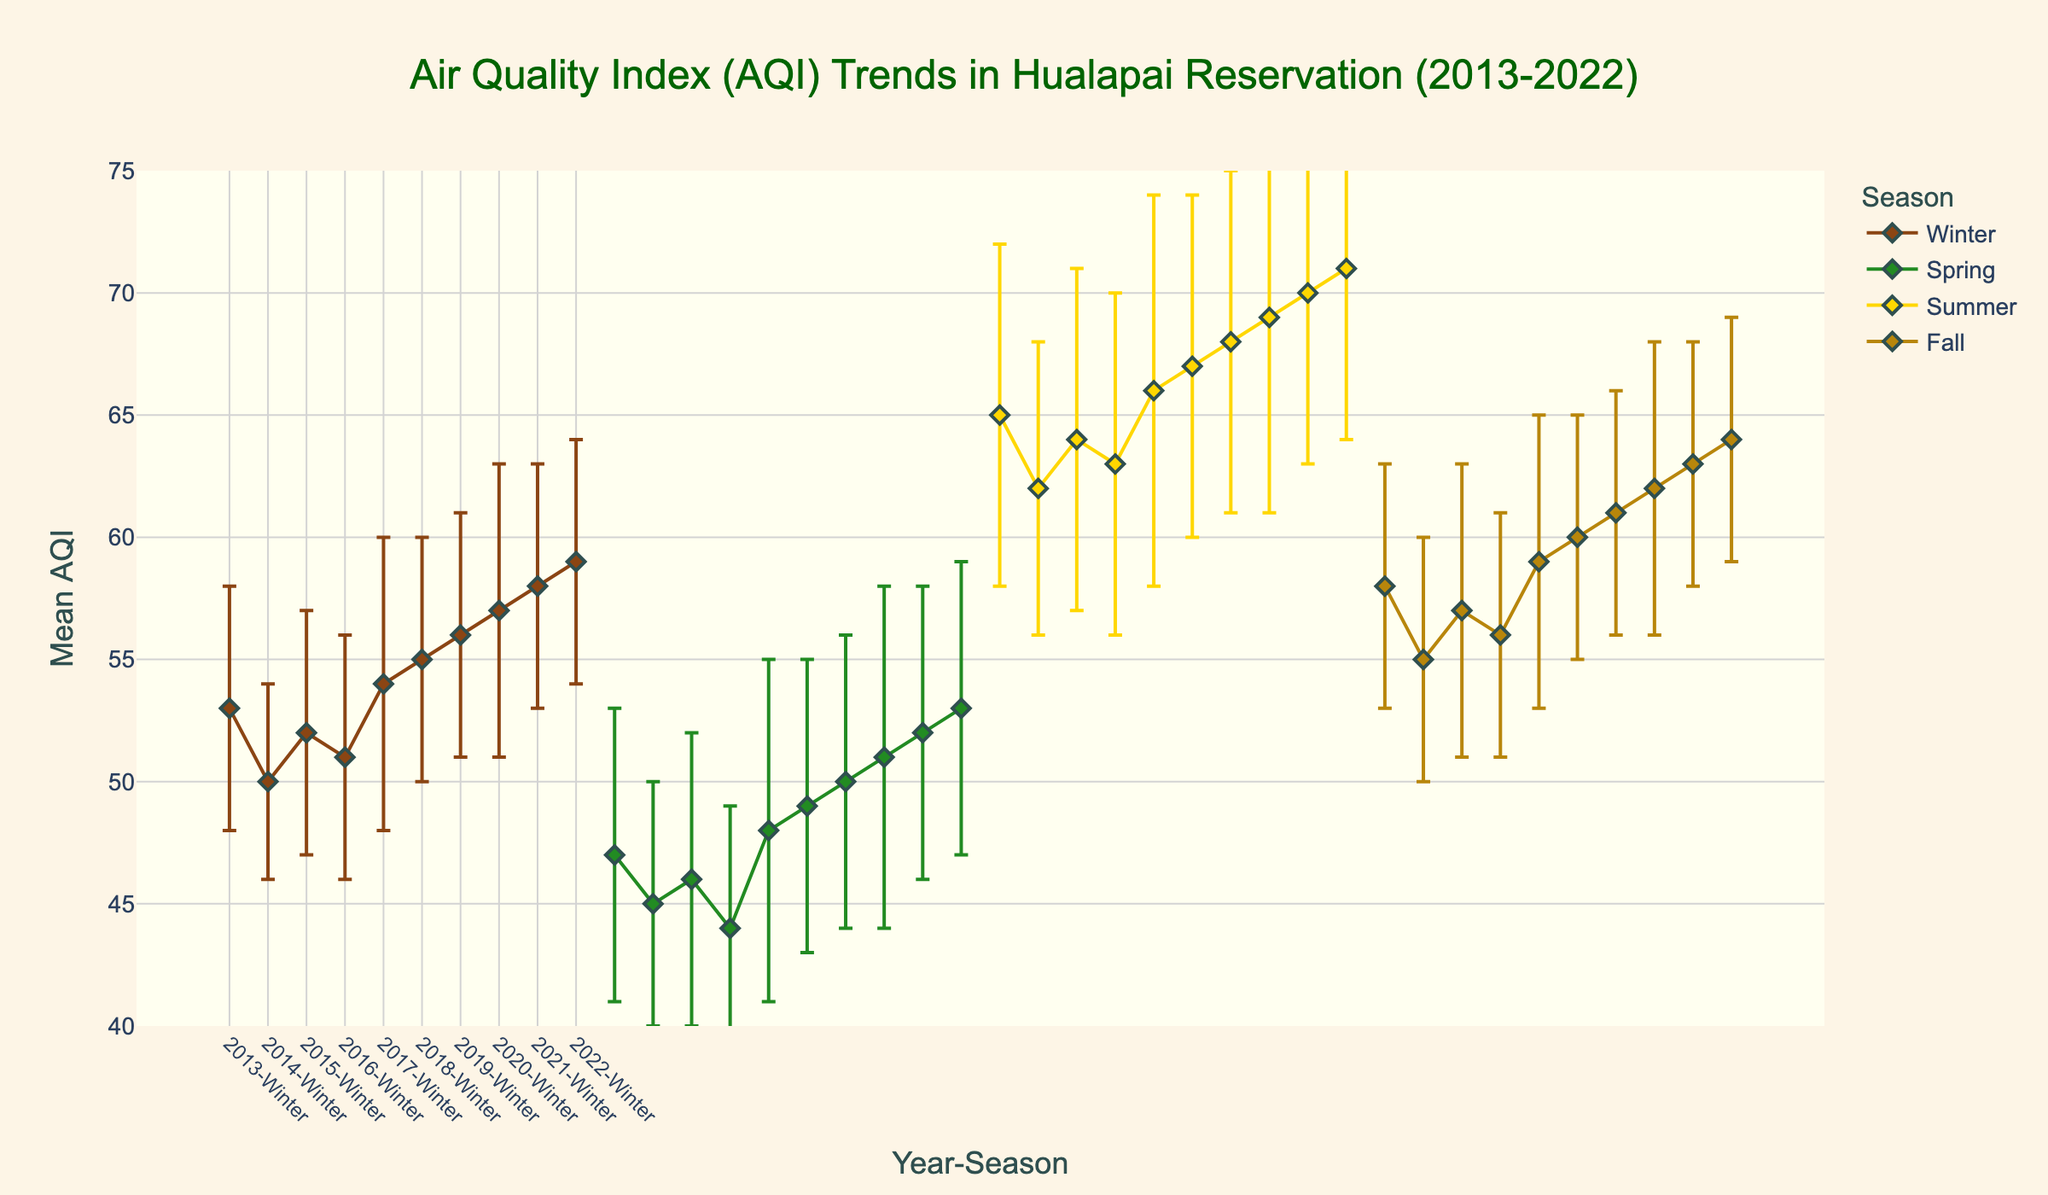What is the title of the figure? The title of the figure is located at the top center and is in a larger font. It reads "Air Quality Index (AQI) Trends in Hualapai Reservation (2013-2022)"
Answer: Air Quality Index (AQI) Trends in Hualapai Reservation (2013-2022) What are the x-axis and y-axis labels? The x-axis label is displayed horizontally at the bottom of the plot and reads "Year-Season". The y-axis label is displayed vertically on the left side of the plot and reads "Mean AQI"
Answer: Year-Season, Mean AQI Which season has the highest average AQI in 2020? By looking at the 2020 section of the figure and comparing the data points for each season, the season with the highest AQI is Summer (value is 69)
Answer: Summer What is the color representation for Winter? The scatter plot uses different colors for each season. Winter is represented by brown color
Answer: Brown Which year had the lowest average Spring AQI, and what was its value? By comparing the Spring data points for all years, the lowest average Spring AQI value is in 2016 with a value of 44. This can be found by identifying the lowest Spring data point on the plot
Answer: 2016, 44 In which season is the mean AQI trend significantly increasing over the decade? Analyzing the trend lines for all seasons from 2013 to 2022, Summer's AQI shows a clear increasing trend, growing from 65 in 2013 to 71 in 2022
Answer: Summer What is the range of AQI values displayed on the y-axis? Reviewing the y-axis, the AQI values range from 40 to 75
Answer: 40 to 75 Compare the AQI for Fall in 2017 and 2021. Which year had a higher AQI and by how much? Fall in 2017 has an AQI of 59, while Fall in 2021 has an AQI of 63. The difference is 63 - 59 = 4
Answer: 2021, 4 How do the error bars for Summer in 2015 and Spring in 2020 compare? For Summer in 2015, the error bar shows a standard deviation of 7, while for Spring in 2020, the standard deviation is 7 as well. Since both are the same, there's no difference
Answer: They are equal Which years show a continuous increase in average AQI during Winter? To identify the years with a continuous increase in Winter AQI, observe the Winter points from each year. Starting from 2018 to 2022 (55, 56, 57, 58, 59), all show increasing AQI each year
Answer: 2018 to 2022 